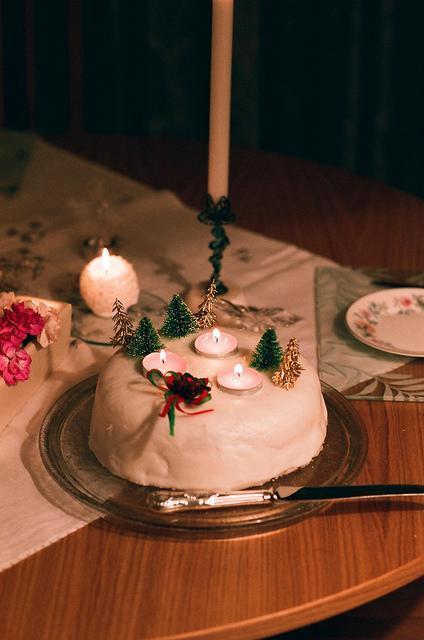How many train cars can you see in this picture?
Give a very brief answer. 0. 